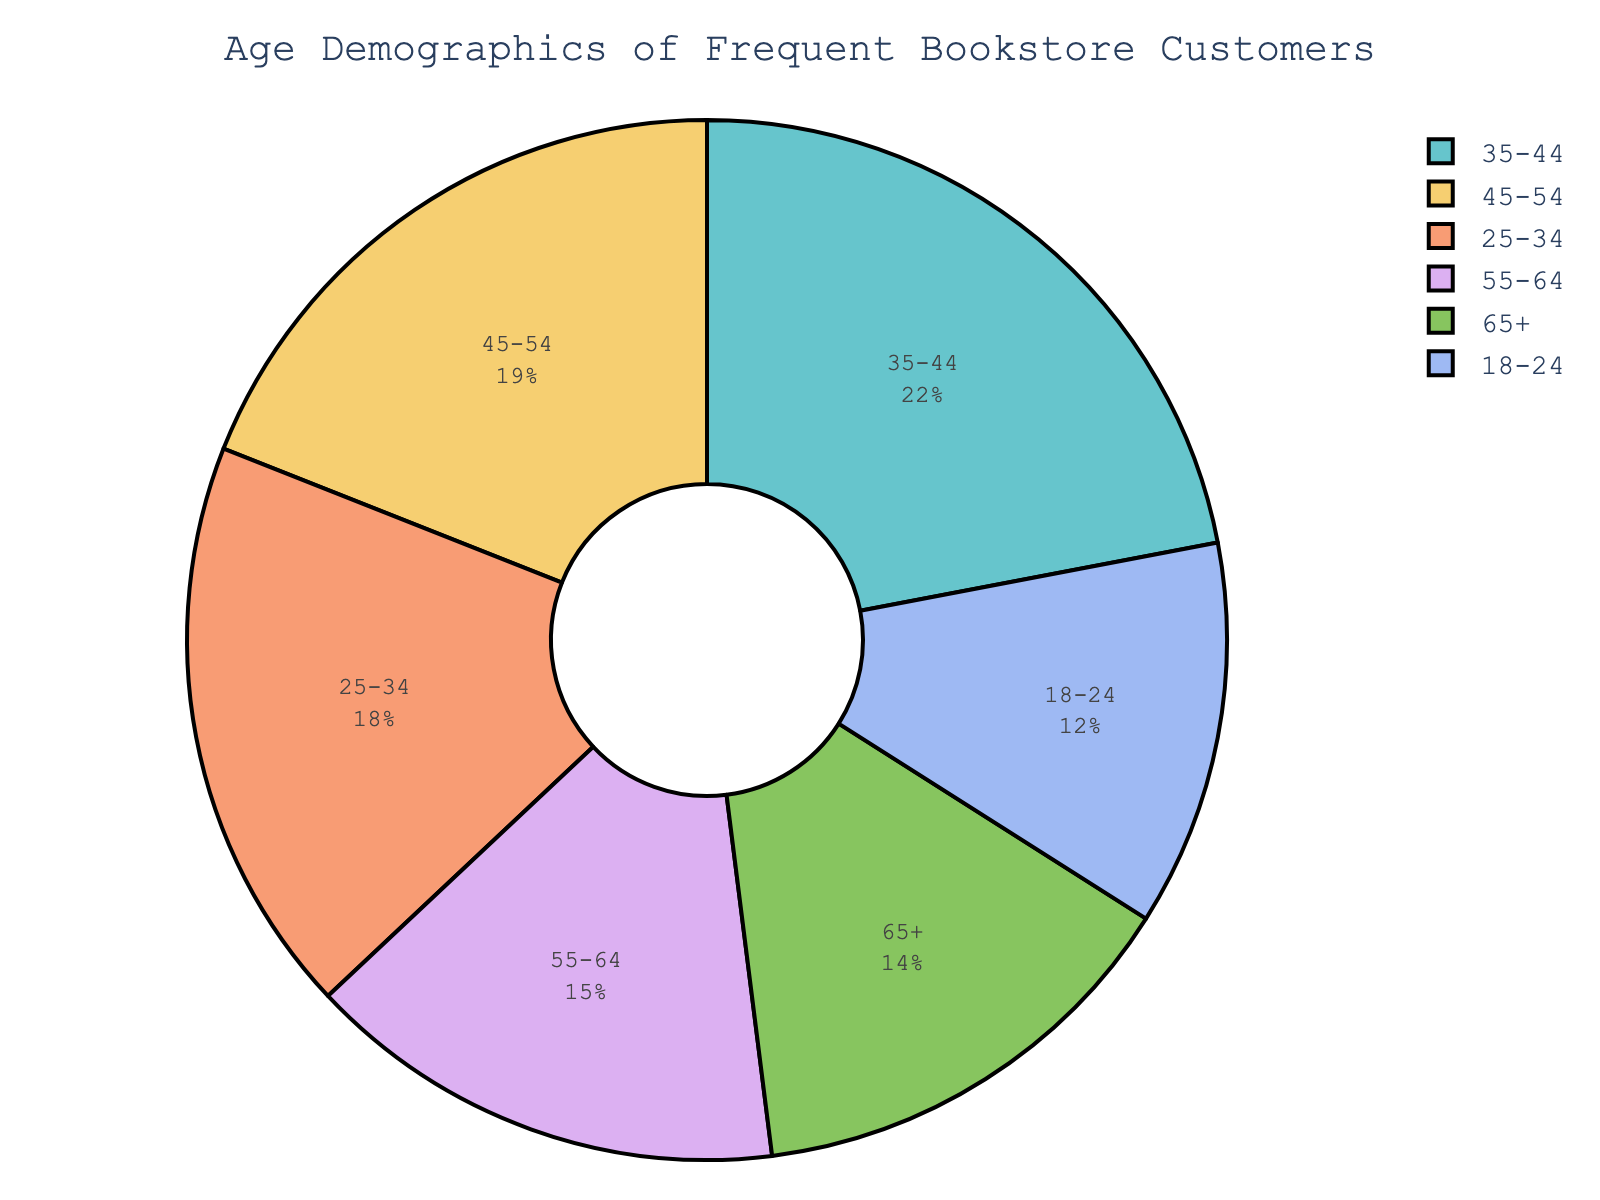What percentage of customers are aged 25-34? Look at the slice labeled "25-34" in the pie chart. The percentage indicated is 18%.
Answer: 18% Which age group has the smallest percentage of frequent customers? Observe the slices of the pie chart and compare the percentages. The slice labeled "18-24" has the smallest percentage at 12%.
Answer: 18-24 Which age group has the largest percentage of frequent customers? Observe the slices of the pie chart and identify the one with the largest percentage. The slice labeled "35-44" has the largest percentage at 22%.
Answer: 35-44 How does the percentage of customers aged 45-54 compare to those aged 65+? Compare the sizes of the two slices. The "45-54" age group is larger with 19%, while the "65+" age group has 14%. Therefore, the 45-54 group is larger.
Answer: 45-54 is larger What is the combined percentage of customers aged 55 and above? Add the percentages of the "55-64" and "65+" age groups. That is 15% + 14% = 29%.
Answer: 29% Is the percentage of customers aged 35-44 greater than the sum of those aged 65+ and 18-24? First, sum the percentages of the "65+" and "18-24" age groups: 14% + 12% = 26%. Compare this result to the percentage for the "35-44" age group which is 22%. The 35-44 age group has a lower percentage.
Answer: No Which two consecutive age groups have the largest combined percentage of frequent customers? Calculate combined percentages for consecutive age groups:
- 18-24 and 25-34: 12% + 18% = 30%
- 25-34 and 35-44: 18% + 22% = 40%
- 35-44 and 45-54: 22% + 19% = 41%
- 45-54 and 55-64: 19% + 15% = 34%
- 55-64 and 65+: 15% + 14% = 29%
The age groups "35-44" and "45-54" have the largest combined percentage at 41%.
Answer: 35-44 and 45-54 If we combine all age groups below 55, what is their percentage, and is it greater than the percentage of the group 55 and above? Sum the percentages of all age groups below 55: (12% for 18-24) + (18% for 25-34) + (22% for 35-44) + (19% for 45-54) = 71%. The combined percentage of the 55 and above groups is 29%. 71% is greater than 29%.
Answer: 71%, Yes 